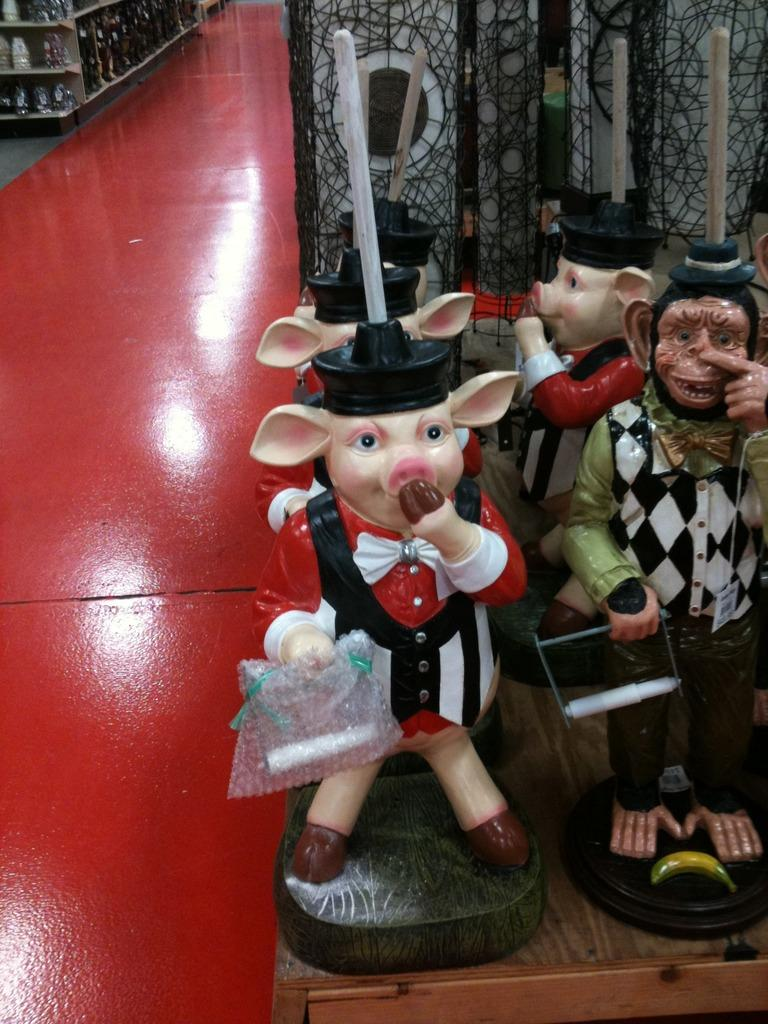What type of surface is the toys placed on in the image? There are toys on a wooden table in the image. What can be seen on the racks in the image? Objects are on racks in the image. What color is the floor in the image? The floor has a red color in the image. How many slaves are visible in the image? There are no slaves present in the image. What type of twig can be seen on the wooden table? There is no twig present on the wooden table in the image. 